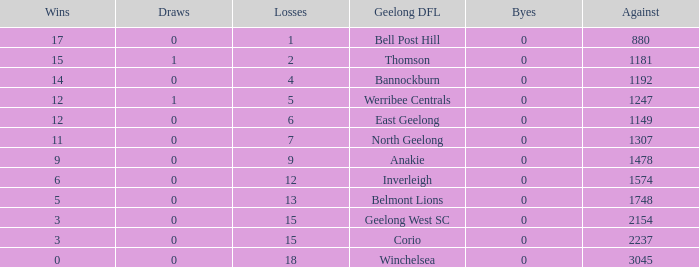What is the total number of losses where the byes were greater than 0? 0.0. 